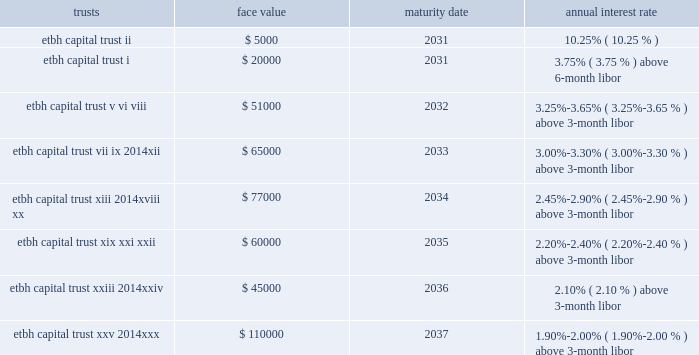Percent of the unpaid principal balance of its residential mortgage loans ; one percent of 30 percent of its total assets ; or one-twentieth of its outstanding fhlb advances .
In addition , the company must maintain qualified collateral equal to 110 to 115 percent of its advances , depending on the collateral type .
These advances are secured with specific mortgage loans and mortgage-backed securities .
At december 31 , 2007 and 2006 , the company pledged $ 16.8 billion and $ 12.9 billion , respectively , of the one- to four-family and home equity loans as collateral .
Other 2014etbh raises capital through the formation of trusts , which sell trust preferred stock in the capital markets .
The capital securities must be redeemed in whole at the due date , which is generally 30 years after issuance .
Each trust issued floating rate cumulative preferred securities , at par with a liquidation amount of $ 1000 per capital security .
The trusts use the proceeds from the sale of issuances to purchase floating rate junior subordinated debentures issued by etbh , which guarantees the trust obligations and contributes proceeds from the sale of its subordinated debentures to e*trade bank in the form of a capital contribution .
During 2007 , etbh formed three trusts , etbh capital trust xxviii , etbh capital trust xxix and etbh capital trust xxx .
These trusts issued a total of 60000 shares of floating rate cumulative preferred securities for a total of $ 60.0 million .
Net proceeds from these issuances were invested in floating rate junior subordinated debentures that mature in 2037 and have variable rates of 1.90% ( 1.90 % ) , 1.95% ( 1.95 % ) , or 2.10% ( 2.10 % ) above the three- month libor , payable quarterly .
During 2006 , etbh formed five trusts , etbh capital trust xxiii through etbh capital trust xxvii .
These trusts issued a total of 95000 shares of floating rate cumulative preferred securities for a total of $ 95 million .
Net proceeds from these issuances were invested in floating rate junior subordinated debentures that mature in 2036 or 2037 and have variable rates of 1.95% ( 1.95 % ) or 2.10% ( 2.10 % ) above the three-month libor , payable quarterly .
In april 2007 , etbh called etbh capital trust iv which had sold $ 10.0 million of trust preferred stock in the capital markets in 2002 and generated a loss of $ 0.3 million .
In june 2007 , etbh called telebank capital trust i which had sold $ 9.0 million of trust preferred stock in the capital markets in 1997 , and generated a loss of $ 0.9 million .
In december 2006 , etbh called etbh capital trust iii which had sold $ 15.0 million of trust preferred stock in the capital markets in 2001 , and generated a loss of $ 0.5 million .
The face values of outstanding trusts at december 31 , 2007 are shown below ( dollars in thousands ) : trusts maturity date annual interest rate .
The company also has multiple term loans from financial institutions .
These loans are collateralized by equipment .
Borrowings under these term loans bear interest at 1% ( 1 % ) above libor , 0.68% ( 0.68 % ) above libor or 9.30% ( 9.30 % ) .
The company had approximately $ 40 million of principal outstanding under these loans at december 31 , 2007 .
Other borrowings also includes $ 12.0 million of overnight and other short-term borrowings in connection with the federal reserve bank 2019s term investment option and treasury , tax and loan programs .
The company pledged $ 12.0 million of securities to secure these borrowings from the federal reserve bank. .
At december 31 , 2007 what was face values of outstanding trusts with maturity in 2037 to 2033? 
Rationale: at december 31 , 2007 there was $ 1.69 in face values of outstanding trusts 2037 maturities compared to the 2033
Computations: (110000 / 65000)
Answer: 1.69231. 